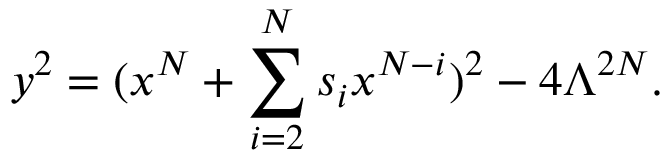<formula> <loc_0><loc_0><loc_500><loc_500>y ^ { 2 } = ( x ^ { N } + \sum _ { i = 2 } ^ { N } s _ { i } x ^ { N - i } ) ^ { 2 } - 4 \Lambda ^ { 2 N } .</formula> 